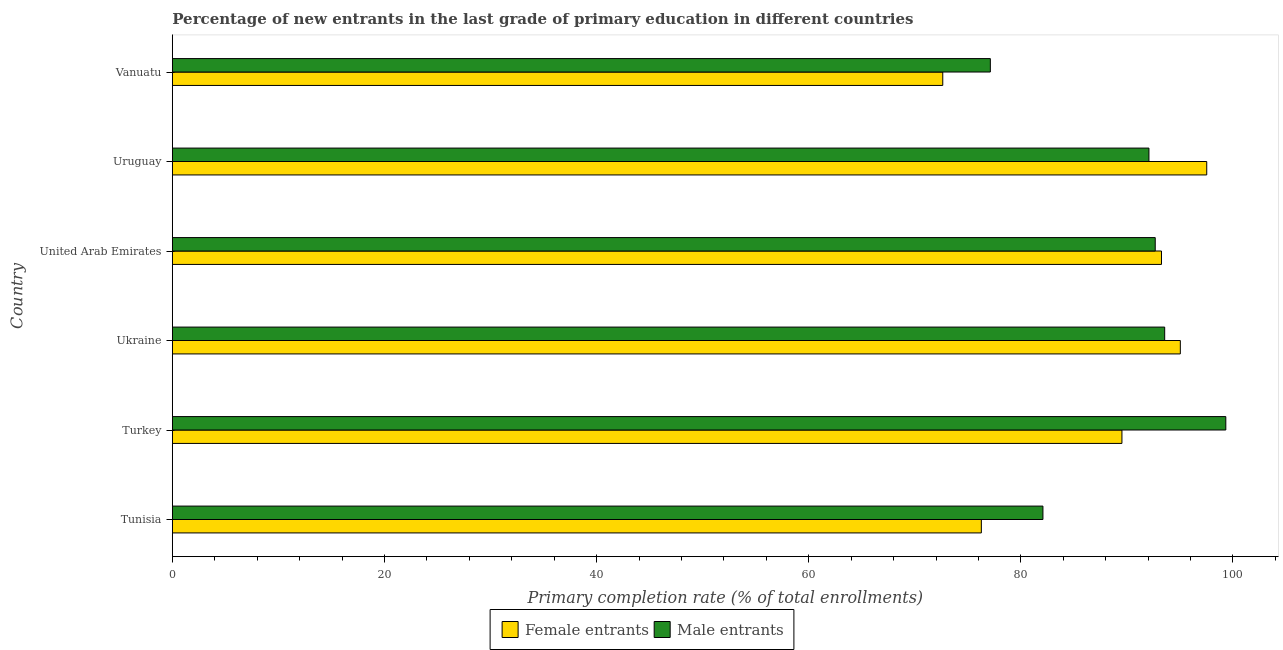How many different coloured bars are there?
Make the answer very short. 2. How many groups of bars are there?
Provide a short and direct response. 6. Are the number of bars on each tick of the Y-axis equal?
Your answer should be compact. Yes. How many bars are there on the 2nd tick from the bottom?
Your answer should be very brief. 2. What is the label of the 3rd group of bars from the top?
Your answer should be compact. United Arab Emirates. What is the primary completion rate of male entrants in Ukraine?
Offer a terse response. 93.56. Across all countries, what is the maximum primary completion rate of male entrants?
Offer a very short reply. 99.32. Across all countries, what is the minimum primary completion rate of female entrants?
Your answer should be very brief. 72.64. In which country was the primary completion rate of female entrants minimum?
Give a very brief answer. Vanuatu. What is the total primary completion rate of female entrants in the graph?
Provide a succinct answer. 524.26. What is the difference between the primary completion rate of female entrants in Turkey and that in Ukraine?
Your answer should be compact. -5.5. What is the difference between the primary completion rate of female entrants in Vanuatu and the primary completion rate of male entrants in Tunisia?
Offer a very short reply. -9.44. What is the average primary completion rate of male entrants per country?
Provide a short and direct response. 89.47. What is the difference between the primary completion rate of male entrants and primary completion rate of female entrants in United Arab Emirates?
Offer a terse response. -0.59. What is the ratio of the primary completion rate of female entrants in Tunisia to that in United Arab Emirates?
Provide a succinct answer. 0.82. Is the primary completion rate of male entrants in Tunisia less than that in United Arab Emirates?
Offer a terse response. Yes. Is the difference between the primary completion rate of male entrants in Ukraine and United Arab Emirates greater than the difference between the primary completion rate of female entrants in Ukraine and United Arab Emirates?
Your response must be concise. No. What is the difference between the highest and the second highest primary completion rate of female entrants?
Keep it short and to the point. 2.49. What is the difference between the highest and the lowest primary completion rate of female entrants?
Your answer should be very brief. 24.89. In how many countries, is the primary completion rate of male entrants greater than the average primary completion rate of male entrants taken over all countries?
Offer a very short reply. 4. What does the 1st bar from the top in United Arab Emirates represents?
Your answer should be very brief. Male entrants. What does the 2nd bar from the bottom in Uruguay represents?
Your answer should be compact. Male entrants. What is the difference between two consecutive major ticks on the X-axis?
Your answer should be compact. 20. Are the values on the major ticks of X-axis written in scientific E-notation?
Offer a terse response. No. Does the graph contain grids?
Your response must be concise. No. Where does the legend appear in the graph?
Keep it short and to the point. Bottom center. What is the title of the graph?
Ensure brevity in your answer.  Percentage of new entrants in the last grade of primary education in different countries. Does "Secondary Education" appear as one of the legend labels in the graph?
Offer a terse response. No. What is the label or title of the X-axis?
Keep it short and to the point. Primary completion rate (% of total enrollments). What is the Primary completion rate (% of total enrollments) in Female entrants in Tunisia?
Make the answer very short. 76.27. What is the Primary completion rate (% of total enrollments) of Male entrants in Tunisia?
Give a very brief answer. 82.08. What is the Primary completion rate (% of total enrollments) in Female entrants in Turkey?
Your answer should be very brief. 89.53. What is the Primary completion rate (% of total enrollments) of Male entrants in Turkey?
Your answer should be very brief. 99.32. What is the Primary completion rate (% of total enrollments) in Female entrants in Ukraine?
Keep it short and to the point. 95.03. What is the Primary completion rate (% of total enrollments) of Male entrants in Ukraine?
Provide a short and direct response. 93.56. What is the Primary completion rate (% of total enrollments) of Female entrants in United Arab Emirates?
Provide a short and direct response. 93.26. What is the Primary completion rate (% of total enrollments) in Male entrants in United Arab Emirates?
Your answer should be very brief. 92.67. What is the Primary completion rate (% of total enrollments) of Female entrants in Uruguay?
Provide a short and direct response. 97.53. What is the Primary completion rate (% of total enrollments) of Male entrants in Uruguay?
Offer a terse response. 92.08. What is the Primary completion rate (% of total enrollments) of Female entrants in Vanuatu?
Provide a succinct answer. 72.64. What is the Primary completion rate (% of total enrollments) of Male entrants in Vanuatu?
Your answer should be very brief. 77.12. Across all countries, what is the maximum Primary completion rate (% of total enrollments) in Female entrants?
Provide a succinct answer. 97.53. Across all countries, what is the maximum Primary completion rate (% of total enrollments) in Male entrants?
Ensure brevity in your answer.  99.32. Across all countries, what is the minimum Primary completion rate (% of total enrollments) of Female entrants?
Ensure brevity in your answer.  72.64. Across all countries, what is the minimum Primary completion rate (% of total enrollments) in Male entrants?
Make the answer very short. 77.12. What is the total Primary completion rate (% of total enrollments) in Female entrants in the graph?
Ensure brevity in your answer.  524.26. What is the total Primary completion rate (% of total enrollments) in Male entrants in the graph?
Make the answer very short. 536.83. What is the difference between the Primary completion rate (% of total enrollments) of Female entrants in Tunisia and that in Turkey?
Provide a succinct answer. -13.26. What is the difference between the Primary completion rate (% of total enrollments) in Male entrants in Tunisia and that in Turkey?
Provide a short and direct response. -17.24. What is the difference between the Primary completion rate (% of total enrollments) of Female entrants in Tunisia and that in Ukraine?
Offer a terse response. -18.76. What is the difference between the Primary completion rate (% of total enrollments) of Male entrants in Tunisia and that in Ukraine?
Your answer should be compact. -11.48. What is the difference between the Primary completion rate (% of total enrollments) in Female entrants in Tunisia and that in United Arab Emirates?
Provide a short and direct response. -16.98. What is the difference between the Primary completion rate (% of total enrollments) in Male entrants in Tunisia and that in United Arab Emirates?
Keep it short and to the point. -10.59. What is the difference between the Primary completion rate (% of total enrollments) in Female entrants in Tunisia and that in Uruguay?
Provide a short and direct response. -21.25. What is the difference between the Primary completion rate (% of total enrollments) in Male entrants in Tunisia and that in Uruguay?
Provide a succinct answer. -9.99. What is the difference between the Primary completion rate (% of total enrollments) in Female entrants in Tunisia and that in Vanuatu?
Your answer should be compact. 3.64. What is the difference between the Primary completion rate (% of total enrollments) of Male entrants in Tunisia and that in Vanuatu?
Ensure brevity in your answer.  4.96. What is the difference between the Primary completion rate (% of total enrollments) of Female entrants in Turkey and that in Ukraine?
Ensure brevity in your answer.  -5.5. What is the difference between the Primary completion rate (% of total enrollments) of Male entrants in Turkey and that in Ukraine?
Offer a very short reply. 5.76. What is the difference between the Primary completion rate (% of total enrollments) in Female entrants in Turkey and that in United Arab Emirates?
Offer a very short reply. -3.73. What is the difference between the Primary completion rate (% of total enrollments) in Male entrants in Turkey and that in United Arab Emirates?
Provide a succinct answer. 6.66. What is the difference between the Primary completion rate (% of total enrollments) of Female entrants in Turkey and that in Uruguay?
Give a very brief answer. -7.99. What is the difference between the Primary completion rate (% of total enrollments) in Male entrants in Turkey and that in Uruguay?
Keep it short and to the point. 7.25. What is the difference between the Primary completion rate (% of total enrollments) in Female entrants in Turkey and that in Vanuatu?
Your answer should be very brief. 16.89. What is the difference between the Primary completion rate (% of total enrollments) in Male entrants in Turkey and that in Vanuatu?
Keep it short and to the point. 22.2. What is the difference between the Primary completion rate (% of total enrollments) of Female entrants in Ukraine and that in United Arab Emirates?
Ensure brevity in your answer.  1.78. What is the difference between the Primary completion rate (% of total enrollments) in Male entrants in Ukraine and that in United Arab Emirates?
Your answer should be compact. 0.89. What is the difference between the Primary completion rate (% of total enrollments) in Female entrants in Ukraine and that in Uruguay?
Your answer should be compact. -2.49. What is the difference between the Primary completion rate (% of total enrollments) in Male entrants in Ukraine and that in Uruguay?
Provide a short and direct response. 1.48. What is the difference between the Primary completion rate (% of total enrollments) in Female entrants in Ukraine and that in Vanuatu?
Ensure brevity in your answer.  22.4. What is the difference between the Primary completion rate (% of total enrollments) in Male entrants in Ukraine and that in Vanuatu?
Your answer should be very brief. 16.44. What is the difference between the Primary completion rate (% of total enrollments) of Female entrants in United Arab Emirates and that in Uruguay?
Give a very brief answer. -4.27. What is the difference between the Primary completion rate (% of total enrollments) of Male entrants in United Arab Emirates and that in Uruguay?
Your response must be concise. 0.59. What is the difference between the Primary completion rate (% of total enrollments) of Female entrants in United Arab Emirates and that in Vanuatu?
Make the answer very short. 20.62. What is the difference between the Primary completion rate (% of total enrollments) in Male entrants in United Arab Emirates and that in Vanuatu?
Your response must be concise. 15.55. What is the difference between the Primary completion rate (% of total enrollments) in Female entrants in Uruguay and that in Vanuatu?
Offer a terse response. 24.89. What is the difference between the Primary completion rate (% of total enrollments) of Male entrants in Uruguay and that in Vanuatu?
Ensure brevity in your answer.  14.95. What is the difference between the Primary completion rate (% of total enrollments) of Female entrants in Tunisia and the Primary completion rate (% of total enrollments) of Male entrants in Turkey?
Your response must be concise. -23.05. What is the difference between the Primary completion rate (% of total enrollments) in Female entrants in Tunisia and the Primary completion rate (% of total enrollments) in Male entrants in Ukraine?
Your answer should be very brief. -17.29. What is the difference between the Primary completion rate (% of total enrollments) in Female entrants in Tunisia and the Primary completion rate (% of total enrollments) in Male entrants in United Arab Emirates?
Offer a very short reply. -16.39. What is the difference between the Primary completion rate (% of total enrollments) of Female entrants in Tunisia and the Primary completion rate (% of total enrollments) of Male entrants in Uruguay?
Your answer should be compact. -15.8. What is the difference between the Primary completion rate (% of total enrollments) in Female entrants in Tunisia and the Primary completion rate (% of total enrollments) in Male entrants in Vanuatu?
Keep it short and to the point. -0.85. What is the difference between the Primary completion rate (% of total enrollments) in Female entrants in Turkey and the Primary completion rate (% of total enrollments) in Male entrants in Ukraine?
Give a very brief answer. -4.03. What is the difference between the Primary completion rate (% of total enrollments) of Female entrants in Turkey and the Primary completion rate (% of total enrollments) of Male entrants in United Arab Emirates?
Offer a terse response. -3.14. What is the difference between the Primary completion rate (% of total enrollments) of Female entrants in Turkey and the Primary completion rate (% of total enrollments) of Male entrants in Uruguay?
Provide a short and direct response. -2.55. What is the difference between the Primary completion rate (% of total enrollments) of Female entrants in Turkey and the Primary completion rate (% of total enrollments) of Male entrants in Vanuatu?
Ensure brevity in your answer.  12.41. What is the difference between the Primary completion rate (% of total enrollments) in Female entrants in Ukraine and the Primary completion rate (% of total enrollments) in Male entrants in United Arab Emirates?
Ensure brevity in your answer.  2.37. What is the difference between the Primary completion rate (% of total enrollments) in Female entrants in Ukraine and the Primary completion rate (% of total enrollments) in Male entrants in Uruguay?
Ensure brevity in your answer.  2.96. What is the difference between the Primary completion rate (% of total enrollments) of Female entrants in Ukraine and the Primary completion rate (% of total enrollments) of Male entrants in Vanuatu?
Offer a very short reply. 17.91. What is the difference between the Primary completion rate (% of total enrollments) in Female entrants in United Arab Emirates and the Primary completion rate (% of total enrollments) in Male entrants in Uruguay?
Your response must be concise. 1.18. What is the difference between the Primary completion rate (% of total enrollments) of Female entrants in United Arab Emirates and the Primary completion rate (% of total enrollments) of Male entrants in Vanuatu?
Your answer should be very brief. 16.14. What is the difference between the Primary completion rate (% of total enrollments) in Female entrants in Uruguay and the Primary completion rate (% of total enrollments) in Male entrants in Vanuatu?
Provide a short and direct response. 20.4. What is the average Primary completion rate (% of total enrollments) in Female entrants per country?
Keep it short and to the point. 87.38. What is the average Primary completion rate (% of total enrollments) in Male entrants per country?
Offer a very short reply. 89.47. What is the difference between the Primary completion rate (% of total enrollments) in Female entrants and Primary completion rate (% of total enrollments) in Male entrants in Tunisia?
Keep it short and to the point. -5.81. What is the difference between the Primary completion rate (% of total enrollments) in Female entrants and Primary completion rate (% of total enrollments) in Male entrants in Turkey?
Offer a terse response. -9.79. What is the difference between the Primary completion rate (% of total enrollments) of Female entrants and Primary completion rate (% of total enrollments) of Male entrants in Ukraine?
Offer a terse response. 1.48. What is the difference between the Primary completion rate (% of total enrollments) of Female entrants and Primary completion rate (% of total enrollments) of Male entrants in United Arab Emirates?
Offer a terse response. 0.59. What is the difference between the Primary completion rate (% of total enrollments) of Female entrants and Primary completion rate (% of total enrollments) of Male entrants in Uruguay?
Make the answer very short. 5.45. What is the difference between the Primary completion rate (% of total enrollments) of Female entrants and Primary completion rate (% of total enrollments) of Male entrants in Vanuatu?
Keep it short and to the point. -4.49. What is the ratio of the Primary completion rate (% of total enrollments) in Female entrants in Tunisia to that in Turkey?
Offer a very short reply. 0.85. What is the ratio of the Primary completion rate (% of total enrollments) of Male entrants in Tunisia to that in Turkey?
Give a very brief answer. 0.83. What is the ratio of the Primary completion rate (% of total enrollments) of Female entrants in Tunisia to that in Ukraine?
Give a very brief answer. 0.8. What is the ratio of the Primary completion rate (% of total enrollments) of Male entrants in Tunisia to that in Ukraine?
Ensure brevity in your answer.  0.88. What is the ratio of the Primary completion rate (% of total enrollments) of Female entrants in Tunisia to that in United Arab Emirates?
Offer a very short reply. 0.82. What is the ratio of the Primary completion rate (% of total enrollments) of Male entrants in Tunisia to that in United Arab Emirates?
Make the answer very short. 0.89. What is the ratio of the Primary completion rate (% of total enrollments) in Female entrants in Tunisia to that in Uruguay?
Offer a very short reply. 0.78. What is the ratio of the Primary completion rate (% of total enrollments) in Male entrants in Tunisia to that in Uruguay?
Give a very brief answer. 0.89. What is the ratio of the Primary completion rate (% of total enrollments) of Female entrants in Tunisia to that in Vanuatu?
Your response must be concise. 1.05. What is the ratio of the Primary completion rate (% of total enrollments) of Male entrants in Tunisia to that in Vanuatu?
Ensure brevity in your answer.  1.06. What is the ratio of the Primary completion rate (% of total enrollments) in Female entrants in Turkey to that in Ukraine?
Your answer should be very brief. 0.94. What is the ratio of the Primary completion rate (% of total enrollments) in Male entrants in Turkey to that in Ukraine?
Keep it short and to the point. 1.06. What is the ratio of the Primary completion rate (% of total enrollments) in Female entrants in Turkey to that in United Arab Emirates?
Offer a very short reply. 0.96. What is the ratio of the Primary completion rate (% of total enrollments) in Male entrants in Turkey to that in United Arab Emirates?
Keep it short and to the point. 1.07. What is the ratio of the Primary completion rate (% of total enrollments) of Female entrants in Turkey to that in Uruguay?
Your answer should be compact. 0.92. What is the ratio of the Primary completion rate (% of total enrollments) of Male entrants in Turkey to that in Uruguay?
Provide a short and direct response. 1.08. What is the ratio of the Primary completion rate (% of total enrollments) of Female entrants in Turkey to that in Vanuatu?
Provide a short and direct response. 1.23. What is the ratio of the Primary completion rate (% of total enrollments) in Male entrants in Turkey to that in Vanuatu?
Offer a terse response. 1.29. What is the ratio of the Primary completion rate (% of total enrollments) in Male entrants in Ukraine to that in United Arab Emirates?
Make the answer very short. 1.01. What is the ratio of the Primary completion rate (% of total enrollments) in Female entrants in Ukraine to that in Uruguay?
Offer a very short reply. 0.97. What is the ratio of the Primary completion rate (% of total enrollments) in Male entrants in Ukraine to that in Uruguay?
Provide a short and direct response. 1.02. What is the ratio of the Primary completion rate (% of total enrollments) in Female entrants in Ukraine to that in Vanuatu?
Ensure brevity in your answer.  1.31. What is the ratio of the Primary completion rate (% of total enrollments) of Male entrants in Ukraine to that in Vanuatu?
Ensure brevity in your answer.  1.21. What is the ratio of the Primary completion rate (% of total enrollments) of Female entrants in United Arab Emirates to that in Uruguay?
Offer a very short reply. 0.96. What is the ratio of the Primary completion rate (% of total enrollments) of Male entrants in United Arab Emirates to that in Uruguay?
Your answer should be compact. 1.01. What is the ratio of the Primary completion rate (% of total enrollments) in Female entrants in United Arab Emirates to that in Vanuatu?
Offer a very short reply. 1.28. What is the ratio of the Primary completion rate (% of total enrollments) in Male entrants in United Arab Emirates to that in Vanuatu?
Keep it short and to the point. 1.2. What is the ratio of the Primary completion rate (% of total enrollments) of Female entrants in Uruguay to that in Vanuatu?
Ensure brevity in your answer.  1.34. What is the ratio of the Primary completion rate (% of total enrollments) in Male entrants in Uruguay to that in Vanuatu?
Offer a very short reply. 1.19. What is the difference between the highest and the second highest Primary completion rate (% of total enrollments) in Female entrants?
Your response must be concise. 2.49. What is the difference between the highest and the second highest Primary completion rate (% of total enrollments) of Male entrants?
Make the answer very short. 5.76. What is the difference between the highest and the lowest Primary completion rate (% of total enrollments) of Female entrants?
Ensure brevity in your answer.  24.89. What is the difference between the highest and the lowest Primary completion rate (% of total enrollments) of Male entrants?
Your answer should be very brief. 22.2. 